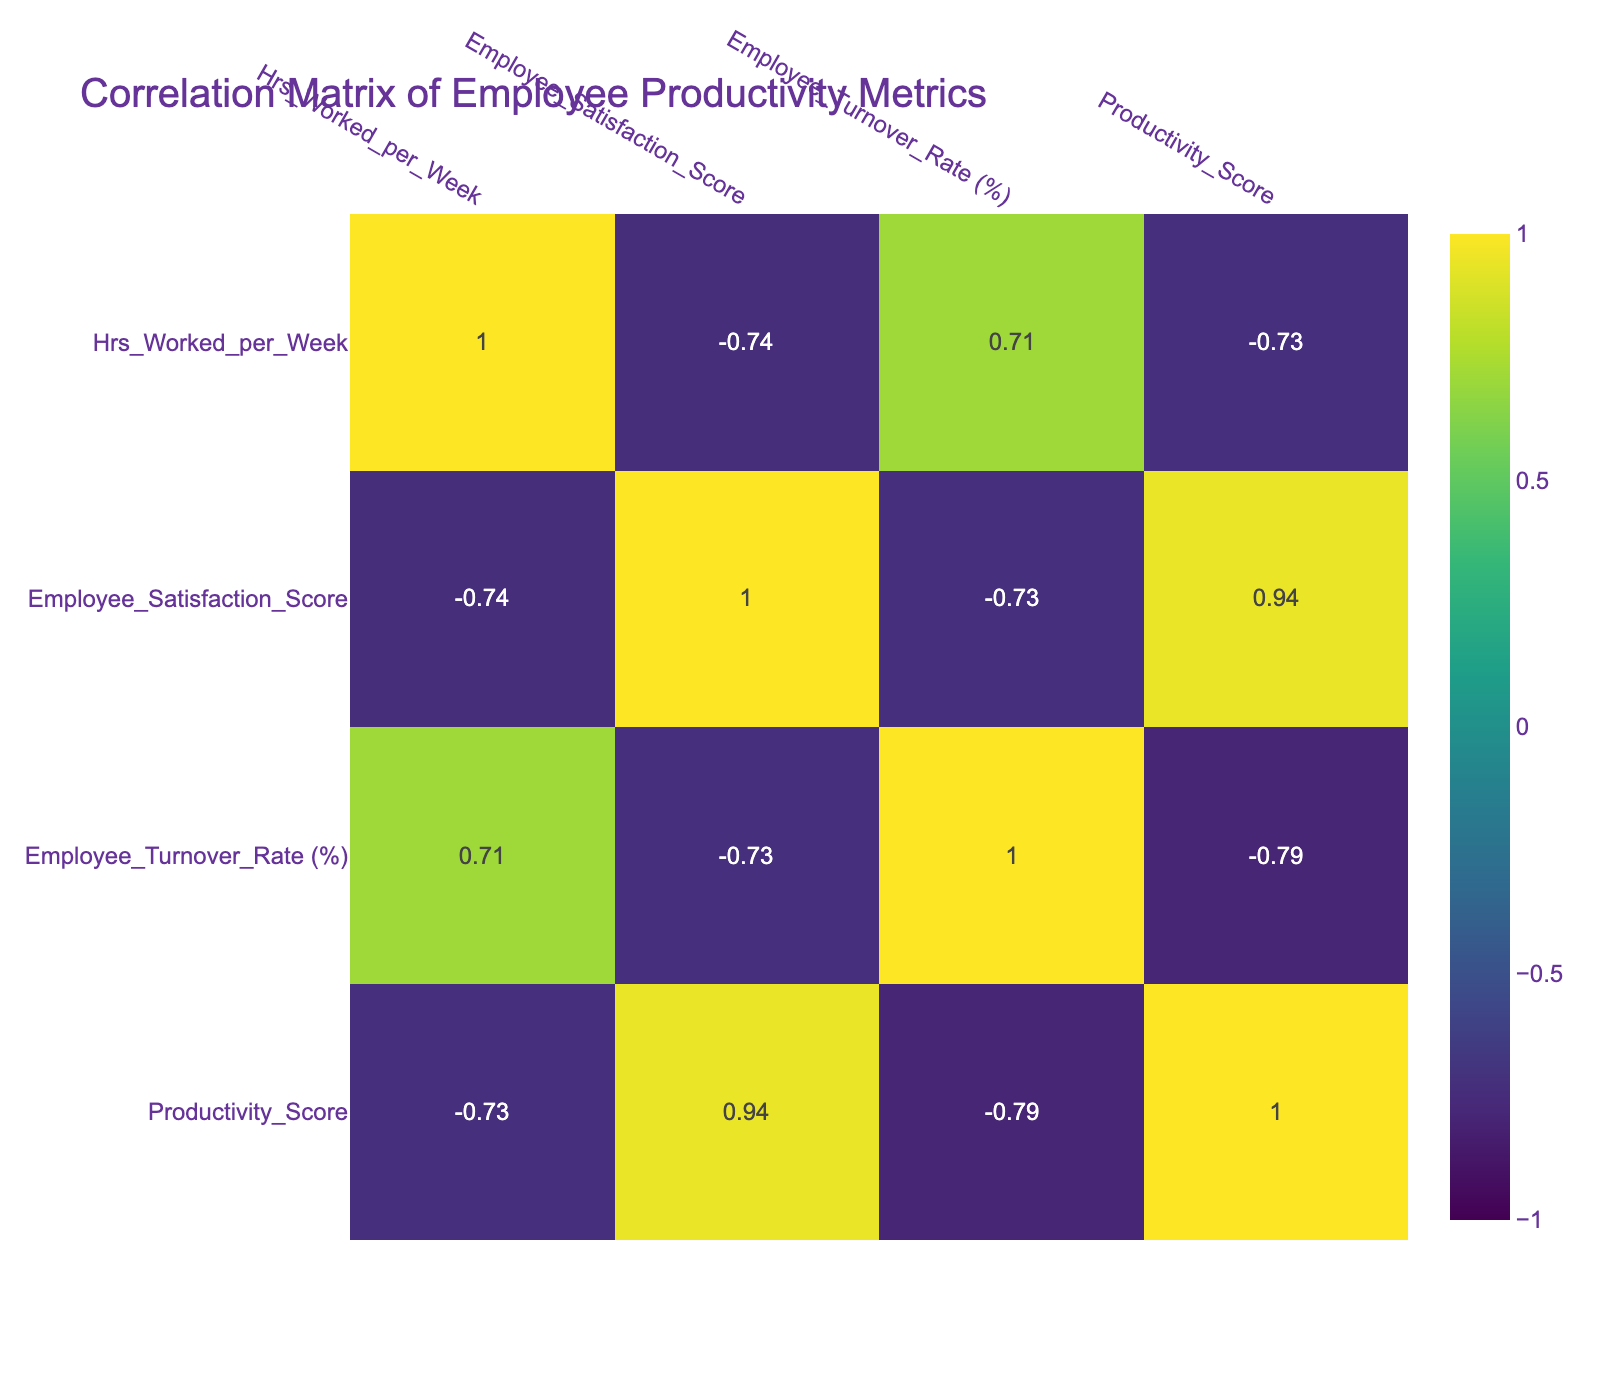What is the productivity score for TechA? The productivity score for TechA can be directly retrieved from the table, which lists TechA in the row with its corresponding metrics. The productivity score is given as 85.
Answer: 85 Which company has the highest employee satisfaction score? By examining the employee satisfaction scores listed, TechJ has the highest score of 9.2.
Answer: 9.2 (TechJ) Is there a correlation between remote work policies and employee turnover rates in the data? The data indicates that fully remote companies (TechA, TechD, TechG, TechJ) generally have lower employee turnover rates compared to in-office companies. This suggests a possible negative correlation, but detailed correlation analysis would confirm this.
Answer: Yes Calculate the average hours worked per week for hybrid companies. Hybrid companies in the data are TechB, TechE, and TechH. Their hours are 40, 40, and 37 respectively. The sum is 117, and dividing by 3 results in an average of 39.
Answer: 39 Which remote work policy is associated with the lowest productivity score? Checking the productivity scores, TechC (in-office) has the lowest score of 75 compared to other firms, indicating that in-office might be negatively impacting productivity in this instance.
Answer: In-Office (TechC) Are fully remote companies all performing better in productivity compared to in-office companies? By comparing the productivity scores, the fully remote companies have scores of 85, 90, 88, and 87, while in-office companies have scores of 75 and 70. Thus, it is accurate to say that fully remote companies are generally performing better in these terms.
Answer: Yes What is the difference in productivity scores between the company with the highest and lowest scores? TechD has the highest score of 90 and TechF has the lowest score of 70. The difference between these scores is 90 - 70, which equals 20.
Answer: 20 Which company's remote work policy contributes to the highest employee satisfaction? TechJ has a fully remote policy and the highest employee satisfaction score of 9.2, thus indicating that its remote work policy contributes positively to employee satisfaction.
Answer: TechJ What is the relation between hours worked per week and productivity scores? From the data, while TechC and TechF (in-office) have high hours worked (45) but lower productivity scores (75 and 70), remote companies tend to have lower hours yet higher scores, suggesting a complex relationship where more hours don't necessarily equate to higher productivity.
Answer: Complex relationship 